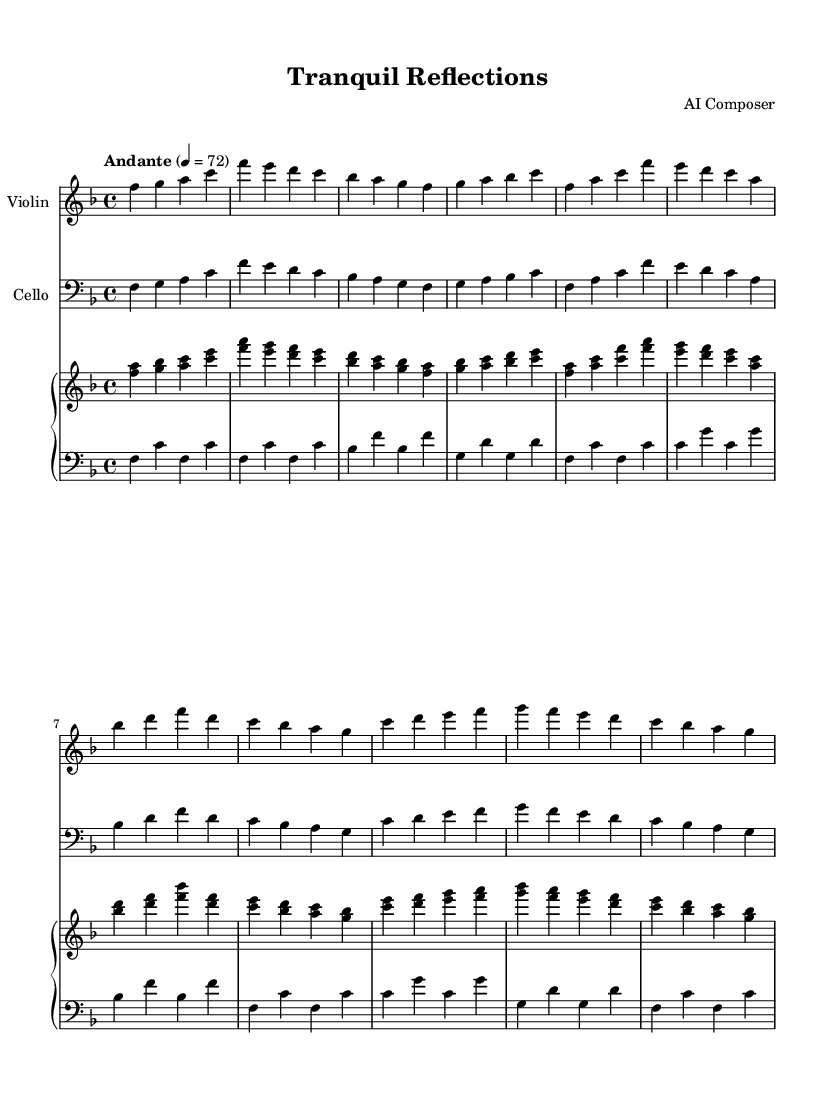What is the key signature of this music? The key signature is indicated by the symbols at the beginning of the stave. In this case, there is one flat (B flat) which signifies that the music is in F major.
Answer: F major What is the time signature of this music? The time signature is shown as two numbers at the beginning of the staff. Here, the "4/4" indicates that there are four beats in each measure and the quarter note gets one beat.
Answer: 4/4 What is the tempo marking for this piece? The tempo marking is found just above the staff, indicating the speed of the music. In this case, "Andante" signifies a moderate pace, commonly associated with a walking speed.
Answer: Andante How many measures are there in the score? Counting each group of notes separated by vertical lines (measures), we see there are a total of 8 measures in each of the sections shown in the sheet music.
Answer: 8 What are the instruments featured in this piece? The instruments are typically labeled at the start of each staff and include "Violin", "Cello", and "Piano". Thus, these three instruments are performing this composition.
Answer: Violin, Cello, Piano Which theme appears first in the score? The first theme can be identified by looking at the sections labeled as "Theme A". This is the initial theme in the composition, separate from other themes or variations.
Answer: Theme A What is the structure of the music based on the themes? By analyzing the layout, we see that the music comprises an introduction followed by Theme A, and then a partial Theme B, reflecting the formal structure often found in classical compositions.
Answer: Introduction, Theme A, Theme B (partial) 